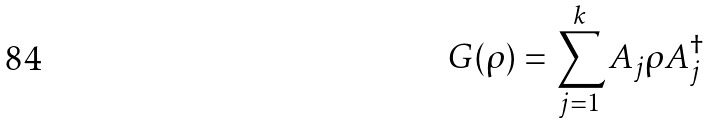<formula> <loc_0><loc_0><loc_500><loc_500>G ( \rho ) = \sum _ { j = 1 } ^ { k } A _ { j } \rho A _ { j } ^ { \dagger }</formula> 